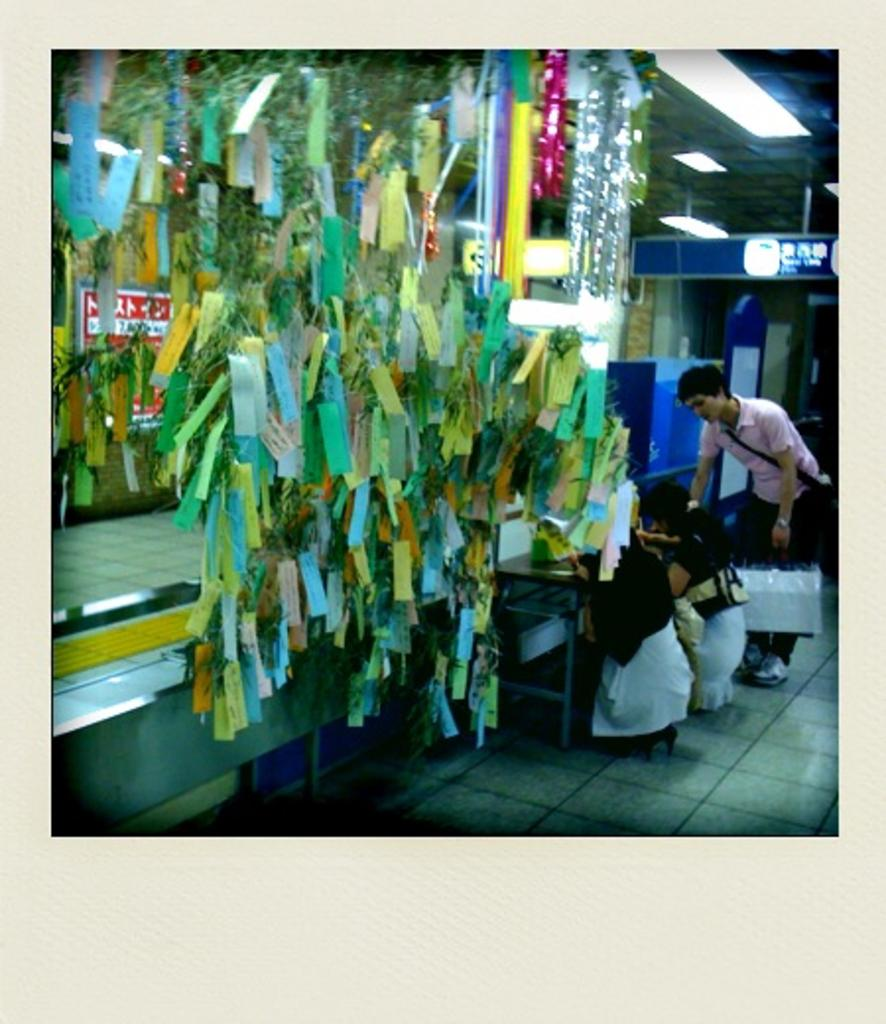What objects are located in the center of the image? There are papers and decors in the center of the image. Where is the person in the image situated? The person is at a table on the right side of the image. What can be seen in the background of the image? There is a floor and a wall visible in the background. How does the person in the image feel shame about the roll on the table? There is no roll or indication of shame present in the image. What type of pin is holding the papers and decors together in the image? There is no pin visible in the image; the papers and decors are not held together by any pin. 